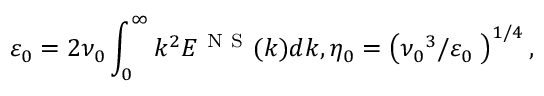Convert formula to latex. <formula><loc_0><loc_0><loc_500><loc_500>{ { \varepsilon } _ { 0 } } = 2 { { \nu } _ { 0 } } \int _ { 0 } ^ { \infty } { { { k } ^ { 2 } } { { E } ^ { N S } } ( k ) d k } , { { \eta } _ { 0 } } = { { \left ( { { { \nu } _ { 0 } } ^ { 3 } } / { { { \varepsilon } _ { 0 } } } \, \right ) } ^ { { 1 } / { 4 } \, } } ,</formula> 